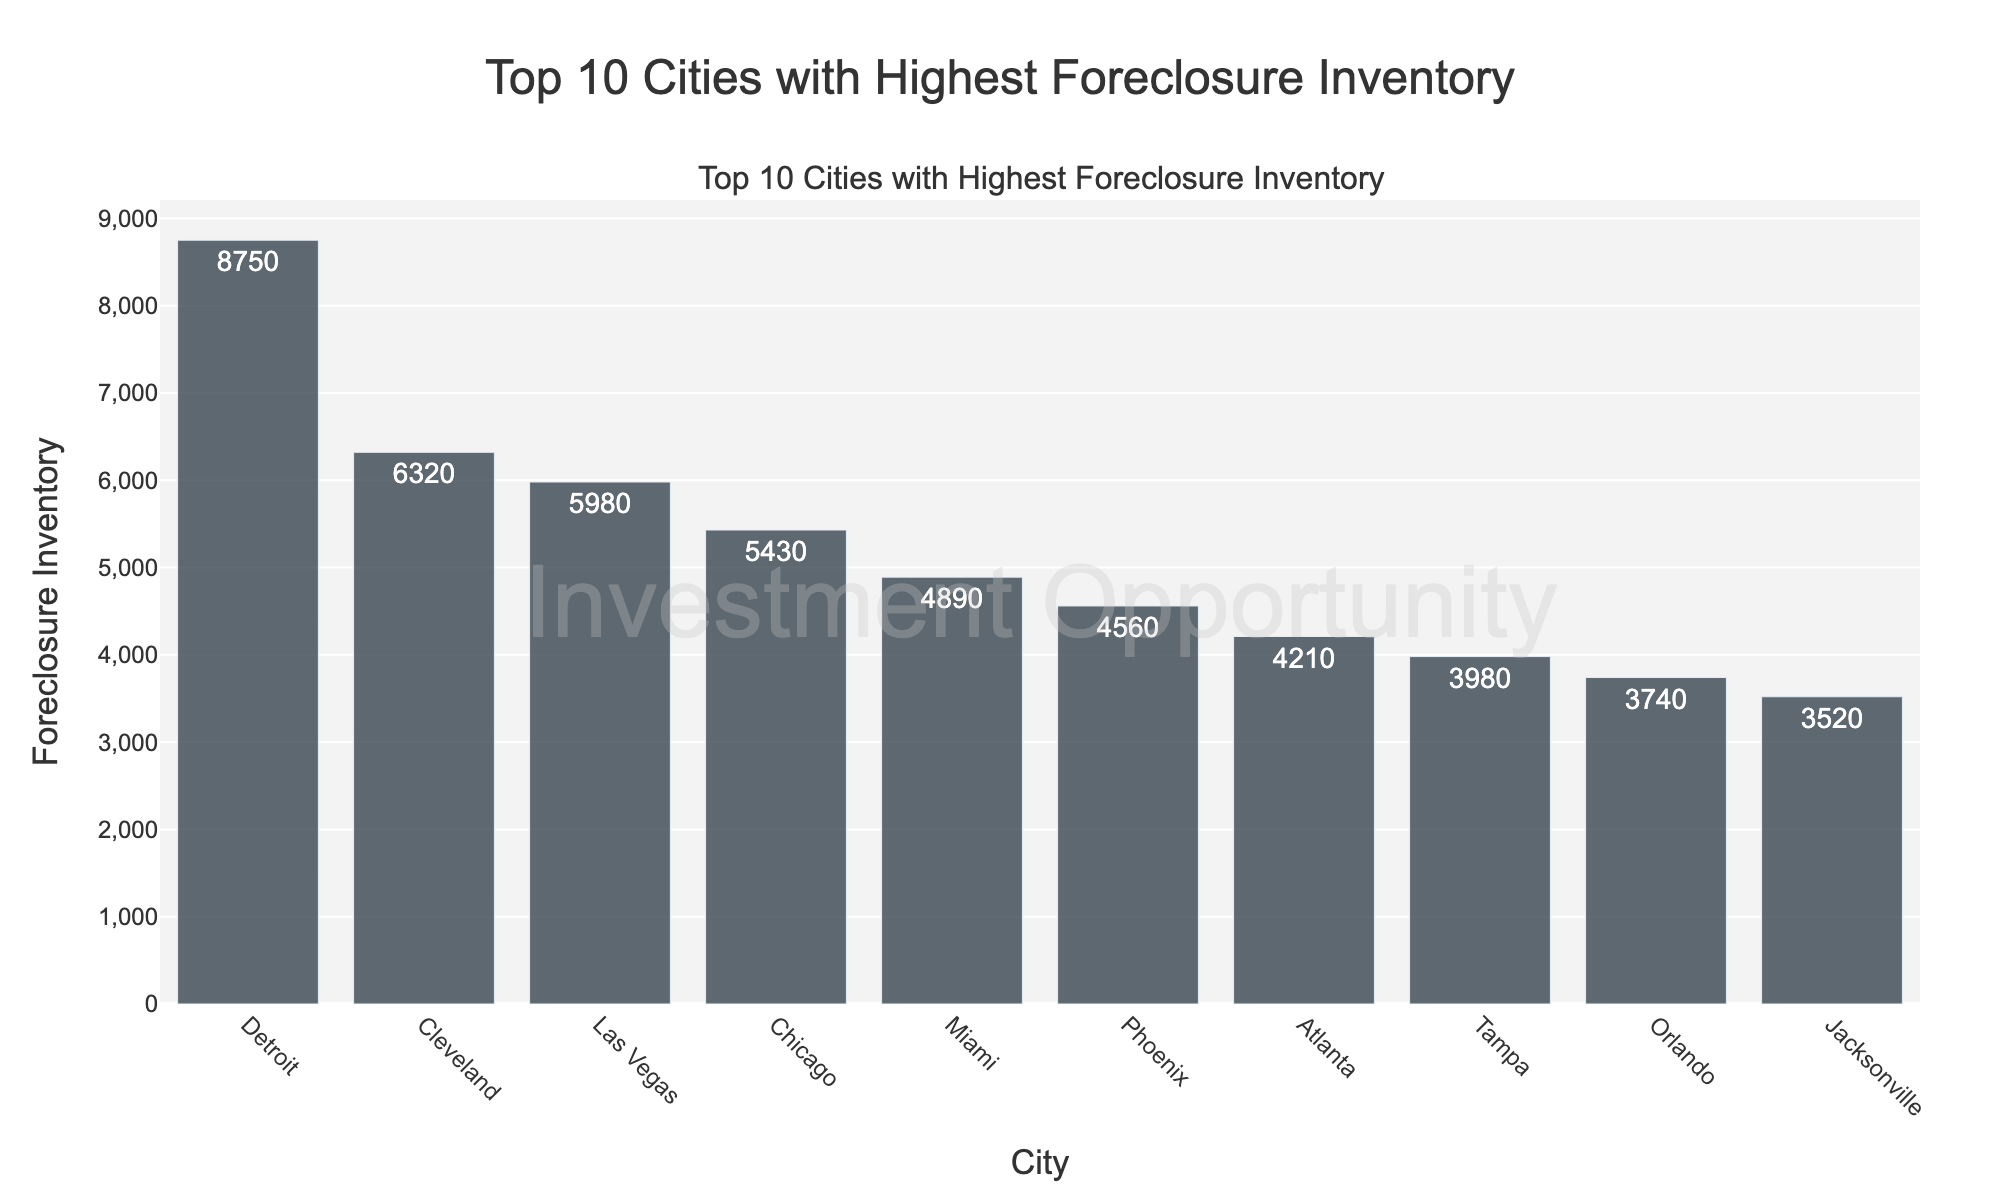What's the city with the highest foreclosure inventory? Observing the bar chart, the city with the tallest bar has the highest foreclosure inventory. The bar for Detroit is the tallest, indicating it has the highest foreclosure inventory.
Answer: Detroit Which city has the lowest foreclosure inventory among the top 10? Looking at the city with the shortest bar in the chart, Jacksonville has the shortest bar, indicating the lowest foreclosure inventory among the top 10 cities.
Answer: Jacksonville What is the total foreclosure inventory for the top 5 cities combined? Sum the foreclosure inventories of Detroit (8750), Cleveland (6320), Las Vegas (5980), Chicago (5430), and Miami (4890). The total is 8750 + 6320 + 5980 + 5430 + 4890 = 31370.
Answer: 31370 Which city has a higher foreclosure inventory, Miami or Atlanta? Compare the heights of the bars for Miami (4890) and Atlanta (4210). The bar for Miami is taller.
Answer: Miami How much higher is Detroit's foreclosure inventory compared to Tampa's? Calculate the difference between Detroit's inventory (8750) and Tampa's (3980). The difference is 8750 - 3980 = 4770.
Answer: 4770 What's the average foreclosure inventory of the listed cities? Sum all the foreclosure inventories and divide by the number of cities (10). The total sum is 8750 + 6320 + 5980 + 5430 + 4890 + 4560 + 4210 + 3980 + 3740 + 3520 = 51380. The average is 51380 / 10 = 5138.
Answer: 5138 What's the difference in foreclosure inventory between Chicago and Phoenix? Calculate the difference between Chicago's inventory (5430) and Phoenix's (4560). The difference is 5430 - 4560 = 870.
Answer: 870 Are there any cities with foreclosure inventories close to 4000? Compare the foreclosure inventories around 4000. Tampa (3980) and Orlando (3740) are close to this number.
Answer: Tampa and Orlando Which city has a higher foreclosure inventory, Las Vegas or Phoenix? Compare the heights of the bars for Las Vegas (5980) and Phoenix (4560). The bar for Las Vegas is taller.
Answer: Las Vegas If the foreclosure inventory in Orlando increased by 500, will it surpass Phoenix's current inventory? Add 500 to Orlando's inventory (3740) to get 3740 + 500 = 4240. Compare it to Phoenix's current inventory (4560). 4240 is less than 4560, so it will not surpass Phoenix.
Answer: No 